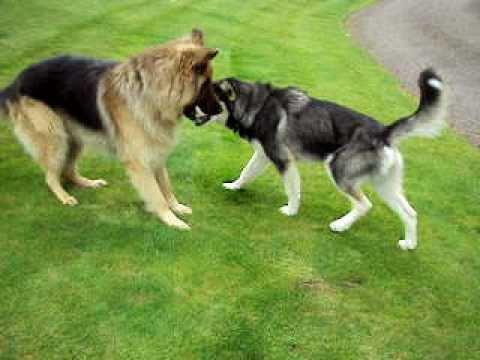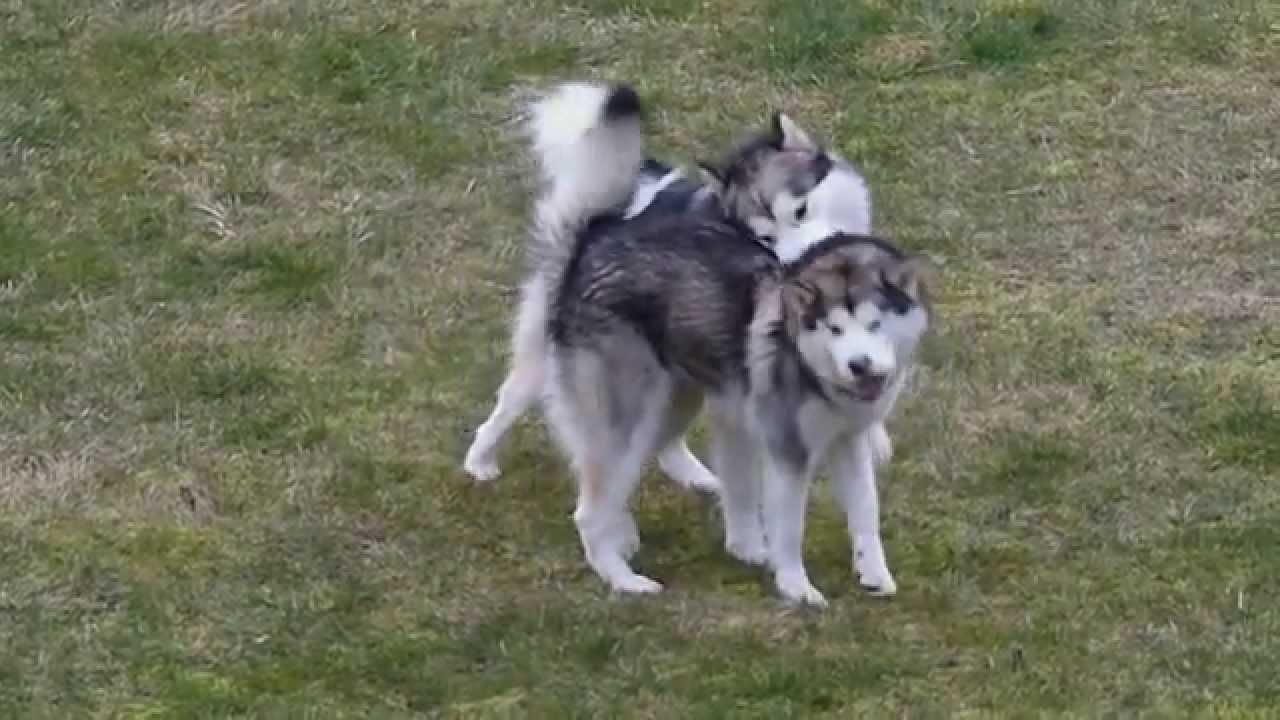The first image is the image on the left, the second image is the image on the right. Evaluate the accuracy of this statement regarding the images: "Each image shows two dogs interacting outdoors, and one image contains two gray-and-white husky dogs.". Is it true? Answer yes or no. Yes. The first image is the image on the left, the second image is the image on the right. For the images shown, is this caption "Two dogs are standing in the grass in the image on the left." true? Answer yes or no. Yes. 